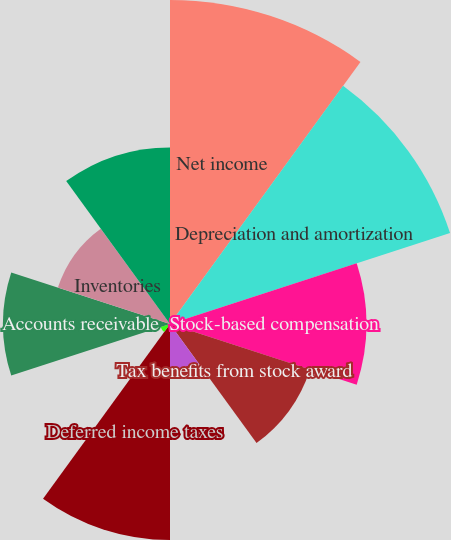<chart> <loc_0><loc_0><loc_500><loc_500><pie_chart><fcel>Net income<fcel>Depreciation and amortization<fcel>Stock-based compensation<fcel>Tax benefits from stock award<fcel>Excess tax benefits from stock<fcel>Deferred income taxes<fcel>Equity investment income net<fcel>Accounts receivable<fcel>Inventories<fcel>Other receivables and other<nl><fcel>19.08%<fcel>17.34%<fcel>11.56%<fcel>8.67%<fcel>2.89%<fcel>12.72%<fcel>0.58%<fcel>9.83%<fcel>6.94%<fcel>10.4%<nl></chart> 